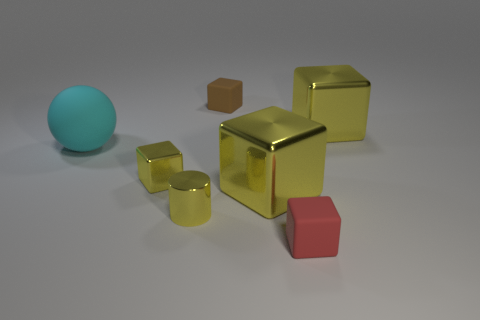Can you describe the lighting and shadows in the image? The lighting in the image is soft and diffused, creating gentle shadows that fall to the right of the objects, suggesting a light source to the upper left. This lighting accentuates the objects' three-dimensional form. 